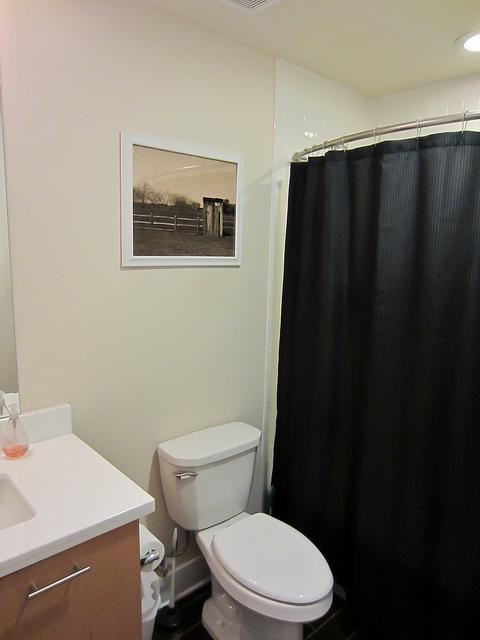What is the pattern on the shower curtains?
Concise answer only. Solid. What is above the toilet?
Quick response, please. Picture. Is there a window in this room?
Concise answer only. No. Does the toilet have a standard or extended seat?
Give a very brief answer. Extended. Is the bathroom decorated in a manly style?
Give a very brief answer. Yes. Is the curtain color a somber choice for a bathroom?
Write a very short answer. Yes. What color is the shower curtain?
Keep it brief. Black. Is this a large bathroom?
Quick response, please. No. 